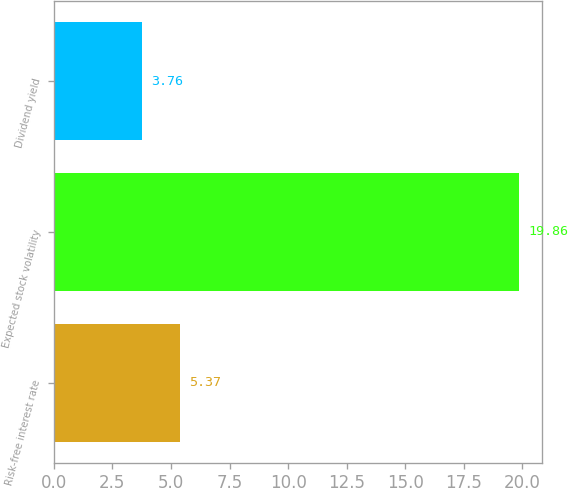Convert chart. <chart><loc_0><loc_0><loc_500><loc_500><bar_chart><fcel>Risk-free interest rate<fcel>Expected stock volatility<fcel>Dividend yield<nl><fcel>5.37<fcel>19.86<fcel>3.76<nl></chart> 